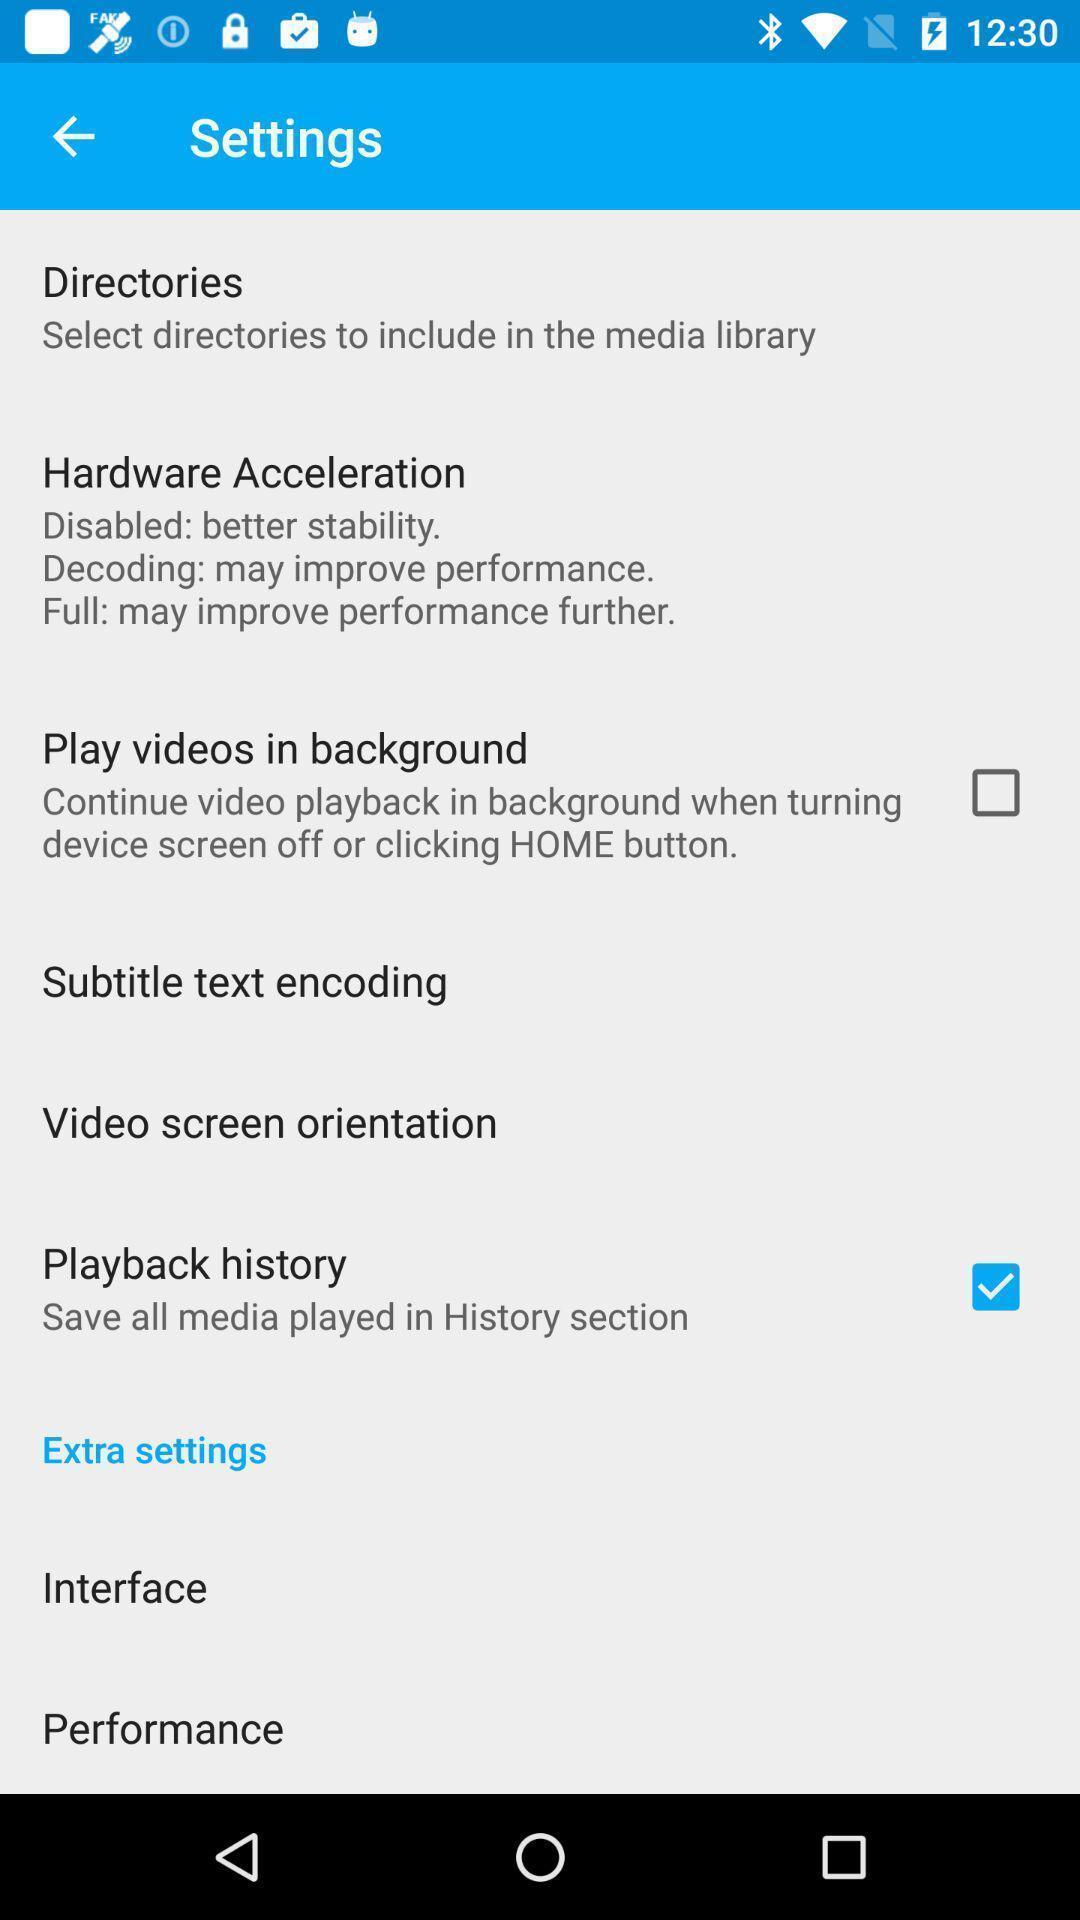Summarize the information in this screenshot. Settings menu for a video player app. 